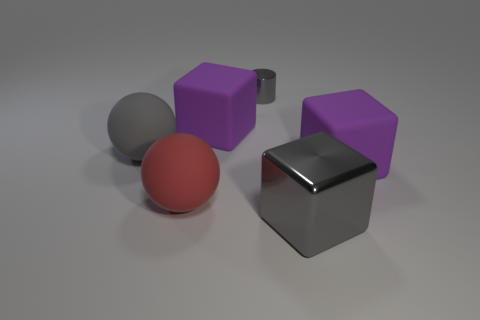There is a gray thing that is in front of the large red matte ball; is there a big red matte thing in front of it?
Provide a succinct answer. No. Are there fewer red balls left of the gray matte thing than gray matte things that are in front of the big gray cube?
Make the answer very short. No. There is a purple rubber cube that is left of the rubber thing that is to the right of the big purple matte thing on the left side of the cylinder; what size is it?
Provide a short and direct response. Large. Do the gray object that is to the left of the metallic cylinder and the tiny gray metallic cylinder have the same size?
Offer a very short reply. No. What number of other things are there of the same material as the big gray sphere
Your answer should be compact. 3. Is the number of big cylinders greater than the number of large red rubber balls?
Your response must be concise. No. What is the material of the big purple cube that is behind the big matte block on the right side of the big purple cube to the left of the big metal cube?
Your answer should be very brief. Rubber. Do the big shiny cube and the tiny cylinder have the same color?
Ensure brevity in your answer.  Yes. Are there any big cubes of the same color as the small shiny cylinder?
Offer a very short reply. Yes. What shape is the gray matte object that is the same size as the red sphere?
Offer a terse response. Sphere. 